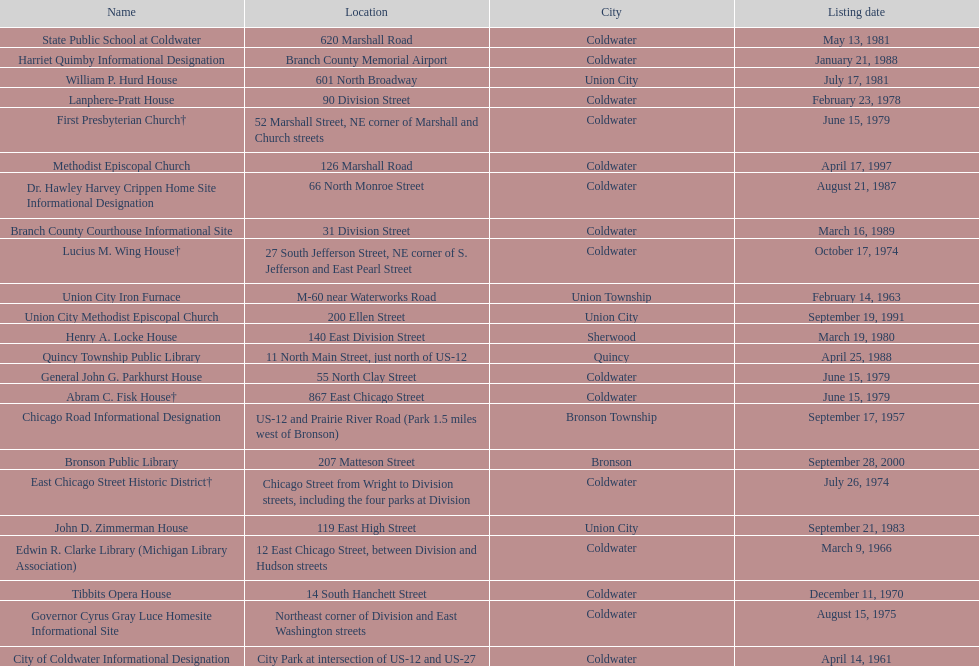How many sites were listed as historical before 1980? 12. 